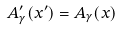Convert formula to latex. <formula><loc_0><loc_0><loc_500><loc_500>A ^ { \prime } _ { \gamma } ( x ^ { \prime } ) = A _ { \gamma } ( x )</formula> 